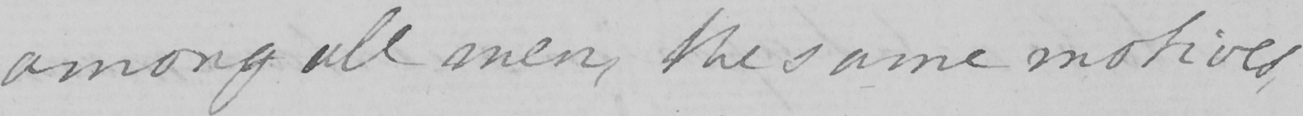Please provide the text content of this handwritten line. among all men , the same motives , 